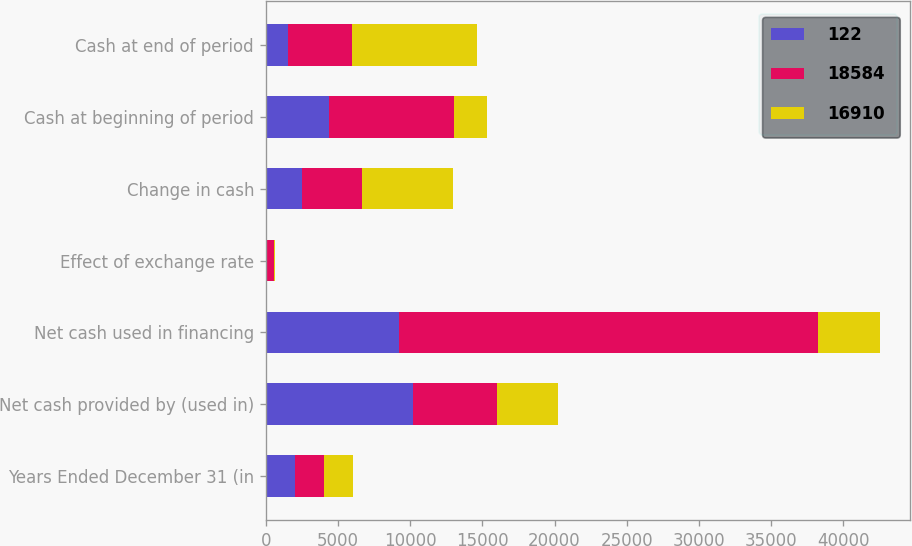Convert chart to OTSL. <chart><loc_0><loc_0><loc_500><loc_500><stacked_bar_chart><ecel><fcel>Years Ended December 31 (in<fcel>Net cash provided by (used in)<fcel>Net cash used in financing<fcel>Effect of exchange rate<fcel>Change in cash<fcel>Cash at beginning of period<fcel>Cash at end of period<nl><fcel>122<fcel>2010<fcel>10225<fcel>9261<fcel>39<fcel>2537<fcel>4400<fcel>1558<nl><fcel>18584<fcel>2009<fcel>5778<fcel>28997<fcel>533<fcel>4102<fcel>8642<fcel>4400<nl><fcel>16910<fcel>2008<fcel>4251<fcel>4251<fcel>38<fcel>6358<fcel>2284<fcel>8642<nl></chart> 